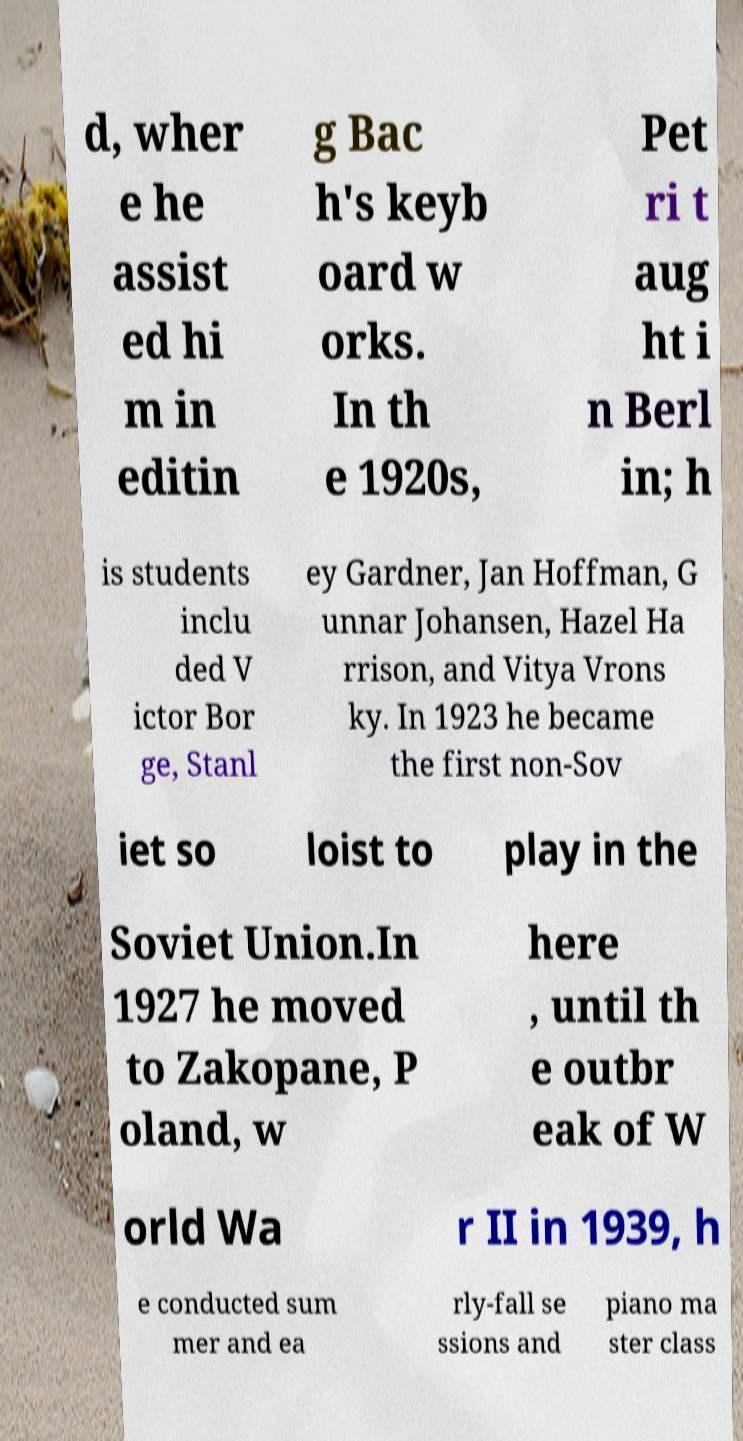Could you assist in decoding the text presented in this image and type it out clearly? d, wher e he assist ed hi m in editin g Bac h's keyb oard w orks. In th e 1920s, Pet ri t aug ht i n Berl in; h is students inclu ded V ictor Bor ge, Stanl ey Gardner, Jan Hoffman, G unnar Johansen, Hazel Ha rrison, and Vitya Vrons ky. In 1923 he became the first non-Sov iet so loist to play in the Soviet Union.In 1927 he moved to Zakopane, P oland, w here , until th e outbr eak of W orld Wa r II in 1939, h e conducted sum mer and ea rly-fall se ssions and piano ma ster class 